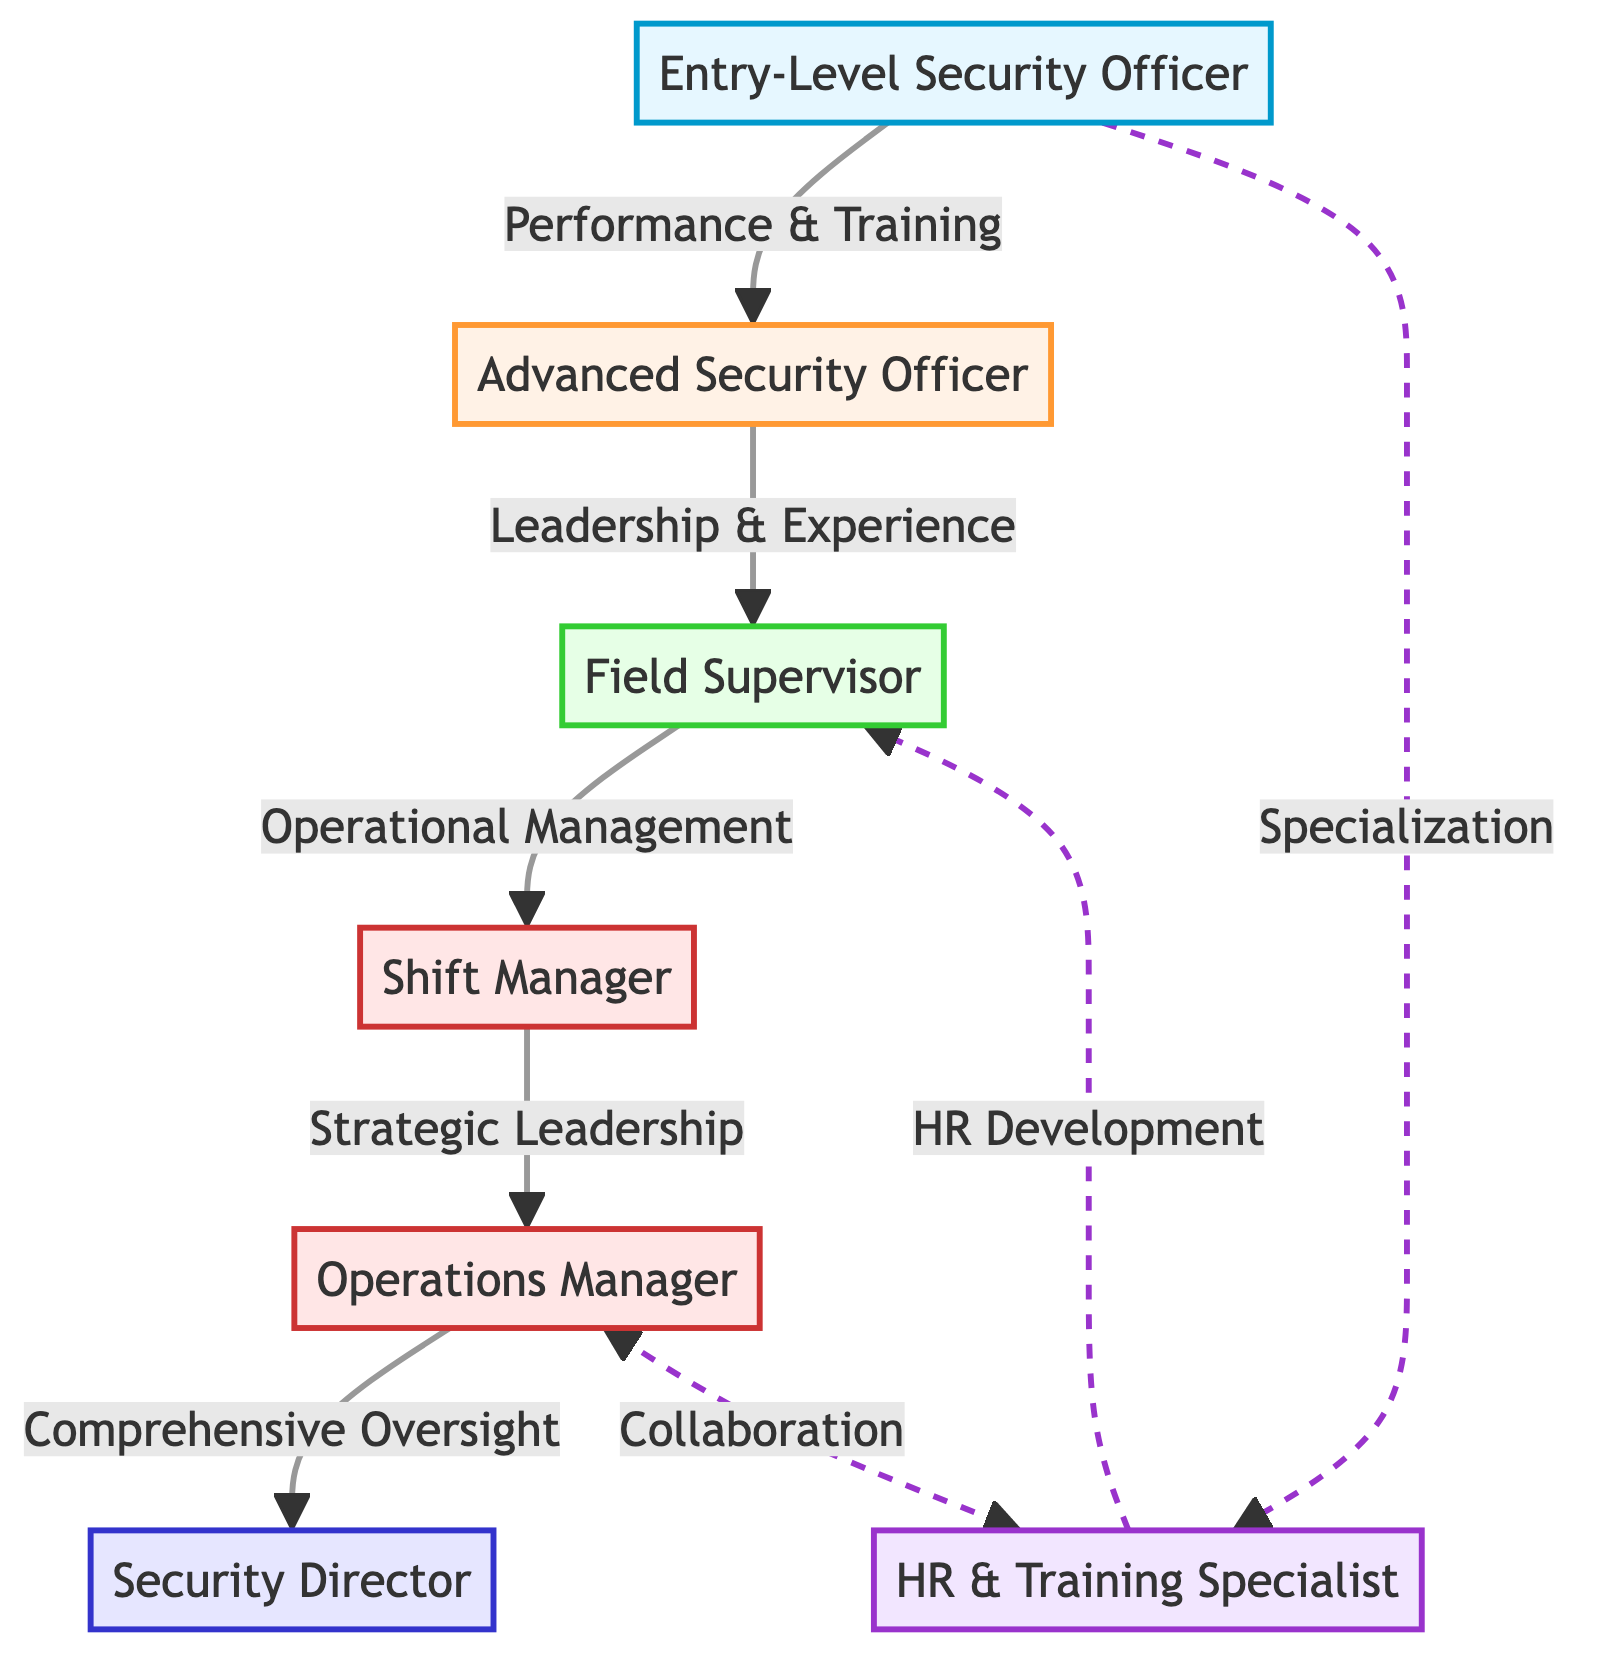What is the highest position in the career progression? The diagram indicates that the highest position in the career progression is the Security Director, represented at the top of the chain.
Answer: Security Director How many levels are there in the career progression? The diagram shows a total of six levels, starting from Entry-Level Security Officer to Security Director.
Answer: 6 What is the prerequisite for becoming a Field Supervisor? To become a Field Supervisor, the prerequisite is to have Leadership and Experience gained from being an Advanced Security Officer.
Answer: Leadership & Experience Which position is connected to entry-level specialization? The diagram shows that Entry-Level Security Officer connects to HR & Training Specialist through a specialization path, implying a focus on specialized training.
Answer: HR & Training Specialist What type of management does an Operations Manager oversee? The diagram indicates that an Operations Manager has Comprehensive Oversight, showing the breadth of management responsibility at this level.
Answer: Comprehensive Oversight What is the dashed line's significance between Operations Manager and HR & Training Specialist? The dashed line indicates a collaborative relationship between the Operations Manager and HR & Training Specialist, highlighting a cross-functional connection in the workflow.
Answer: Collaboration What does the flow from Advanced Security Officer lead to? The flow from Advanced Security Officer proceeds to the Field Supervisor position, indicating that it is a direct advancement in the career path.
Answer: Field Supervisor What is the relationship between Shift Manager and Operations Manager? The diagram indicates that the Shift Manager advances to the Operations Manager through a flow labeled "Strategic Leadership."
Answer: Strategic Leadership Which position involves HR Development in the context of the diagram? According to the diagram, HR Development is specifically associated with the HR & Training Specialist, indicating their role in training and development functions for the team.
Answer: HR Development 